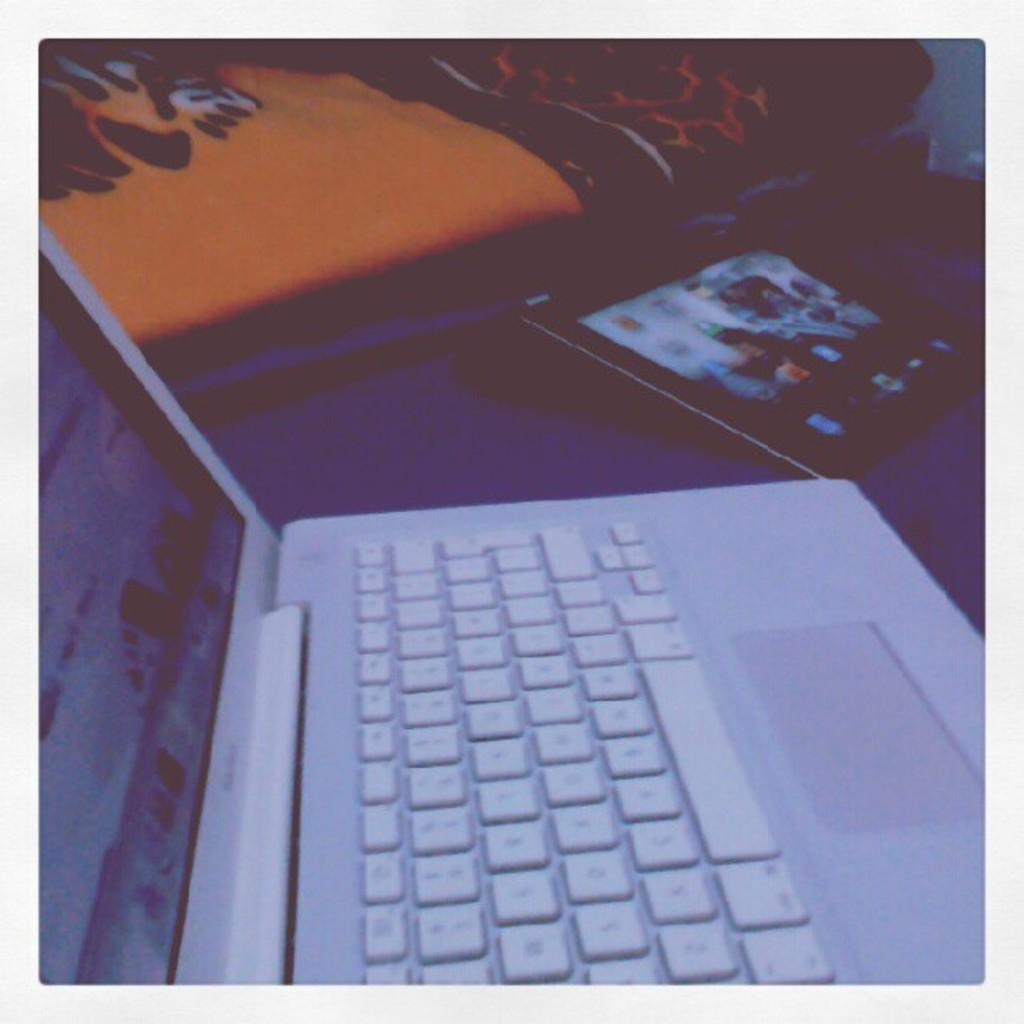What electronic device is visible in the image? There is a laptop in the image. What type of furniture can be seen in the background of the image? There is a bed and a table in the background of the image. What is present on the table in the image? There is a tab on the table in the image. What type of fabric is visible in the background of the image? There is a blanket in the background of the image. What year is the laptop model in the image? The provided facts do not include information about the laptop model or its release year, so it cannot be determined from the image. 